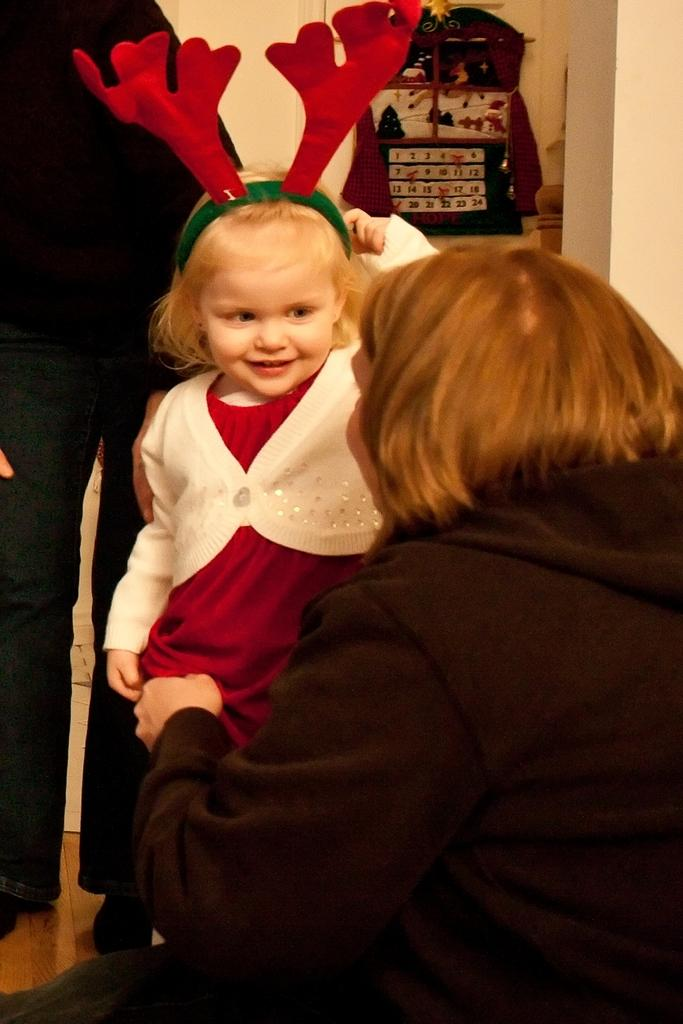Who is present in the image? There are people in the image. Can you describe the age group of one of the individuals in the image? There is a kid in the image. What is the kid's expression in the image? The kid is smiling. What type of zinc system can be seen in the image? There is no zinc system present in the image. What mountain range is visible in the background of the image? There is no mountain range visible in the image. 